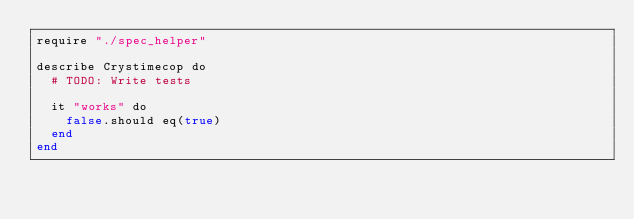<code> <loc_0><loc_0><loc_500><loc_500><_Crystal_>require "./spec_helper"

describe Crystimecop do
  # TODO: Write tests

  it "works" do
    false.should eq(true)
  end
end
</code> 